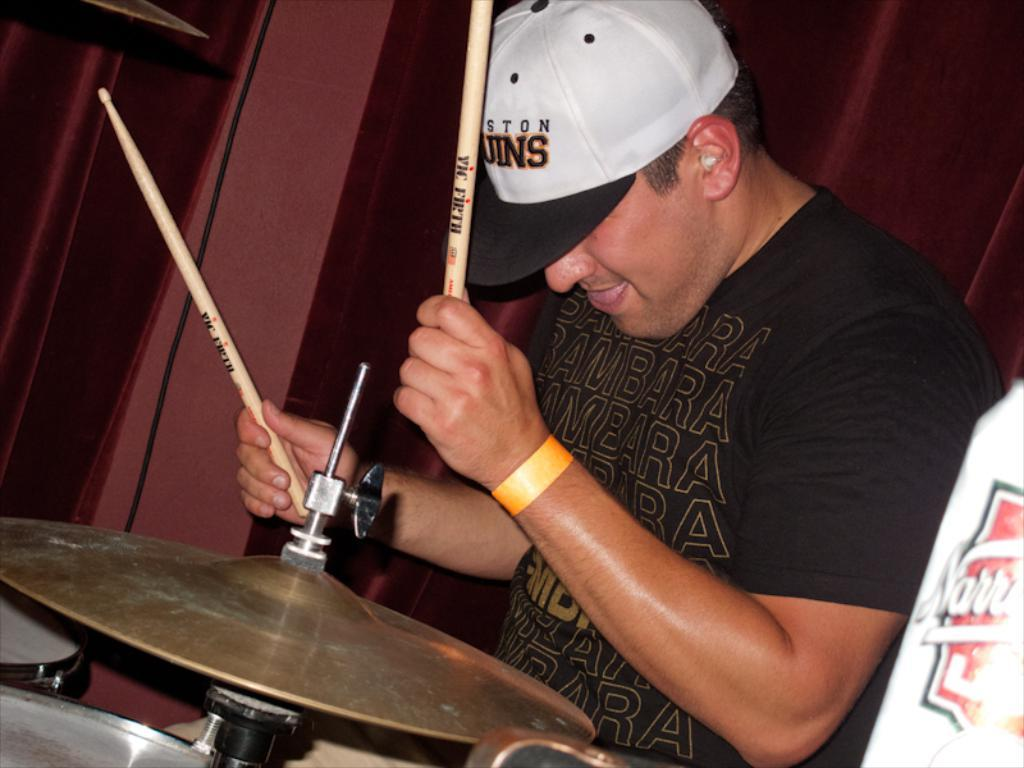<image>
Render a clear and concise summary of the photo. A man wearing a Bambara shirt is playing the drums. 